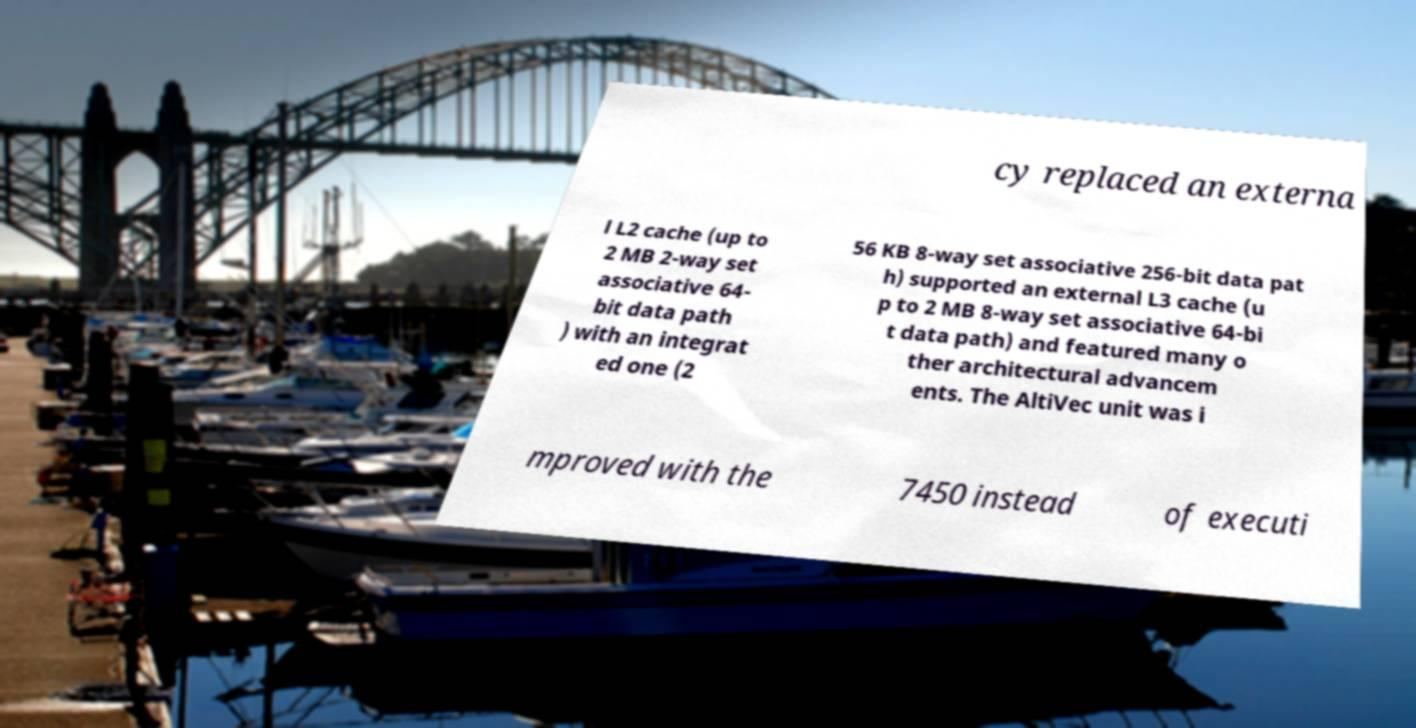Please read and relay the text visible in this image. What does it say? cy replaced an externa l L2 cache (up to 2 MB 2-way set associative 64- bit data path ) with an integrat ed one (2 56 KB 8-way set associative 256-bit data pat h) supported an external L3 cache (u p to 2 MB 8-way set associative 64-bi t data path) and featured many o ther architectural advancem ents. The AltiVec unit was i mproved with the 7450 instead of executi 